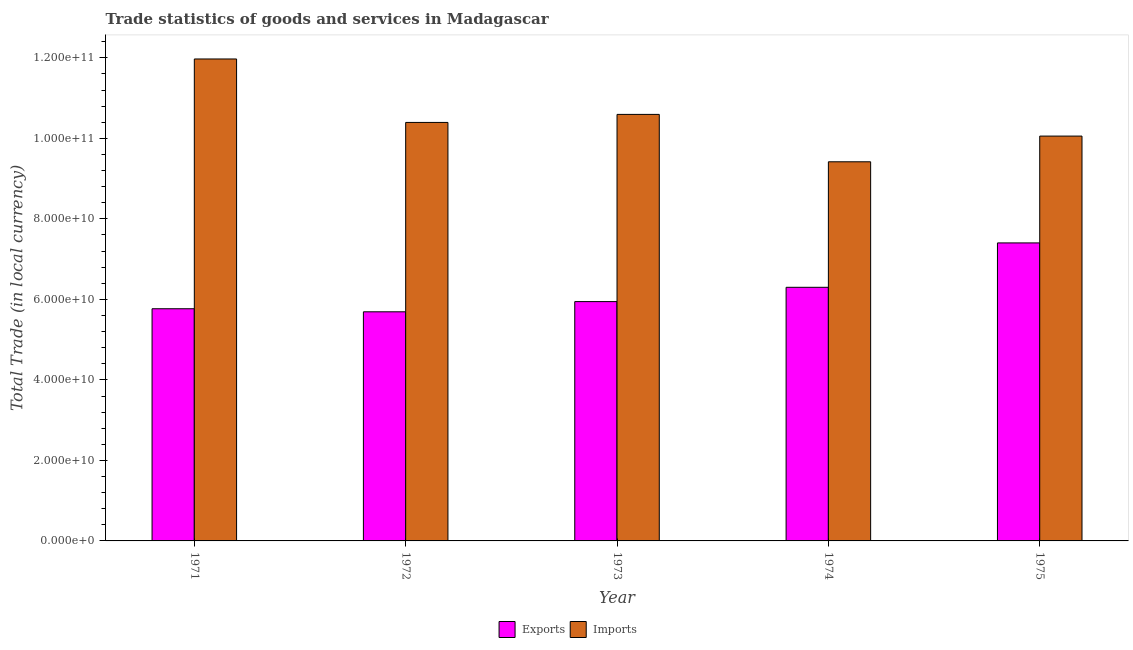How many different coloured bars are there?
Ensure brevity in your answer.  2. Are the number of bars per tick equal to the number of legend labels?
Make the answer very short. Yes. How many bars are there on the 4th tick from the right?
Offer a terse response. 2. What is the label of the 2nd group of bars from the left?
Your response must be concise. 1972. What is the imports of goods and services in 1972?
Your answer should be very brief. 1.04e+11. Across all years, what is the maximum export of goods and services?
Your response must be concise. 7.40e+1. Across all years, what is the minimum imports of goods and services?
Make the answer very short. 9.42e+1. In which year was the imports of goods and services maximum?
Make the answer very short. 1971. In which year was the export of goods and services minimum?
Your response must be concise. 1972. What is the total export of goods and services in the graph?
Ensure brevity in your answer.  3.11e+11. What is the difference between the export of goods and services in 1973 and that in 1974?
Offer a terse response. -3.55e+09. What is the difference between the imports of goods and services in 1973 and the export of goods and services in 1971?
Your answer should be compact. -1.38e+1. What is the average export of goods and services per year?
Give a very brief answer. 6.22e+1. What is the ratio of the imports of goods and services in 1972 to that in 1975?
Provide a succinct answer. 1.03. What is the difference between the highest and the second highest imports of goods and services?
Offer a terse response. 1.38e+1. What is the difference between the highest and the lowest export of goods and services?
Your answer should be compact. 1.71e+1. Is the sum of the imports of goods and services in 1971 and 1975 greater than the maximum export of goods and services across all years?
Provide a succinct answer. Yes. What does the 1st bar from the left in 1973 represents?
Provide a succinct answer. Exports. What does the 1st bar from the right in 1972 represents?
Provide a short and direct response. Imports. How many bars are there?
Your response must be concise. 10. What is the difference between two consecutive major ticks on the Y-axis?
Provide a short and direct response. 2.00e+1. Are the values on the major ticks of Y-axis written in scientific E-notation?
Ensure brevity in your answer.  Yes. Does the graph contain grids?
Give a very brief answer. No. How are the legend labels stacked?
Provide a succinct answer. Horizontal. What is the title of the graph?
Make the answer very short. Trade statistics of goods and services in Madagascar. What is the label or title of the X-axis?
Ensure brevity in your answer.  Year. What is the label or title of the Y-axis?
Keep it short and to the point. Total Trade (in local currency). What is the Total Trade (in local currency) in Exports in 1971?
Give a very brief answer. 5.77e+1. What is the Total Trade (in local currency) in Imports in 1971?
Make the answer very short. 1.20e+11. What is the Total Trade (in local currency) of Exports in 1972?
Provide a succinct answer. 5.69e+1. What is the Total Trade (in local currency) in Imports in 1972?
Provide a short and direct response. 1.04e+11. What is the Total Trade (in local currency) of Exports in 1973?
Your answer should be very brief. 5.95e+1. What is the Total Trade (in local currency) in Imports in 1973?
Your response must be concise. 1.06e+11. What is the Total Trade (in local currency) of Exports in 1974?
Give a very brief answer. 6.30e+1. What is the Total Trade (in local currency) in Imports in 1974?
Your answer should be compact. 9.42e+1. What is the Total Trade (in local currency) in Exports in 1975?
Give a very brief answer. 7.40e+1. What is the Total Trade (in local currency) in Imports in 1975?
Your response must be concise. 1.01e+11. Across all years, what is the maximum Total Trade (in local currency) of Exports?
Offer a terse response. 7.40e+1. Across all years, what is the maximum Total Trade (in local currency) of Imports?
Offer a very short reply. 1.20e+11. Across all years, what is the minimum Total Trade (in local currency) of Exports?
Ensure brevity in your answer.  5.69e+1. Across all years, what is the minimum Total Trade (in local currency) in Imports?
Ensure brevity in your answer.  9.42e+1. What is the total Total Trade (in local currency) in Exports in the graph?
Your answer should be very brief. 3.11e+11. What is the total Total Trade (in local currency) in Imports in the graph?
Offer a very short reply. 5.24e+11. What is the difference between the Total Trade (in local currency) of Exports in 1971 and that in 1972?
Provide a succinct answer. 7.61e+08. What is the difference between the Total Trade (in local currency) of Imports in 1971 and that in 1972?
Provide a succinct answer. 1.58e+1. What is the difference between the Total Trade (in local currency) in Exports in 1971 and that in 1973?
Offer a terse response. -1.77e+09. What is the difference between the Total Trade (in local currency) of Imports in 1971 and that in 1973?
Your answer should be compact. 1.38e+1. What is the difference between the Total Trade (in local currency) in Exports in 1971 and that in 1974?
Keep it short and to the point. -5.32e+09. What is the difference between the Total Trade (in local currency) of Imports in 1971 and that in 1974?
Ensure brevity in your answer.  2.55e+1. What is the difference between the Total Trade (in local currency) of Exports in 1971 and that in 1975?
Your response must be concise. -1.64e+1. What is the difference between the Total Trade (in local currency) of Imports in 1971 and that in 1975?
Provide a succinct answer. 1.92e+1. What is the difference between the Total Trade (in local currency) of Exports in 1972 and that in 1973?
Ensure brevity in your answer.  -2.54e+09. What is the difference between the Total Trade (in local currency) in Imports in 1972 and that in 1973?
Give a very brief answer. -2.00e+09. What is the difference between the Total Trade (in local currency) of Exports in 1972 and that in 1974?
Give a very brief answer. -6.08e+09. What is the difference between the Total Trade (in local currency) of Imports in 1972 and that in 1974?
Provide a succinct answer. 9.78e+09. What is the difference between the Total Trade (in local currency) of Exports in 1972 and that in 1975?
Give a very brief answer. -1.71e+1. What is the difference between the Total Trade (in local currency) of Imports in 1972 and that in 1975?
Ensure brevity in your answer.  3.39e+09. What is the difference between the Total Trade (in local currency) of Exports in 1973 and that in 1974?
Keep it short and to the point. -3.55e+09. What is the difference between the Total Trade (in local currency) of Imports in 1973 and that in 1974?
Keep it short and to the point. 1.18e+1. What is the difference between the Total Trade (in local currency) in Exports in 1973 and that in 1975?
Your answer should be very brief. -1.46e+1. What is the difference between the Total Trade (in local currency) in Imports in 1973 and that in 1975?
Offer a terse response. 5.39e+09. What is the difference between the Total Trade (in local currency) of Exports in 1974 and that in 1975?
Your answer should be very brief. -1.10e+1. What is the difference between the Total Trade (in local currency) in Imports in 1974 and that in 1975?
Offer a terse response. -6.39e+09. What is the difference between the Total Trade (in local currency) in Exports in 1971 and the Total Trade (in local currency) in Imports in 1972?
Ensure brevity in your answer.  -4.63e+1. What is the difference between the Total Trade (in local currency) in Exports in 1971 and the Total Trade (in local currency) in Imports in 1973?
Offer a terse response. -4.83e+1. What is the difference between the Total Trade (in local currency) in Exports in 1971 and the Total Trade (in local currency) in Imports in 1974?
Give a very brief answer. -3.65e+1. What is the difference between the Total Trade (in local currency) of Exports in 1971 and the Total Trade (in local currency) of Imports in 1975?
Your answer should be compact. -4.29e+1. What is the difference between the Total Trade (in local currency) of Exports in 1972 and the Total Trade (in local currency) of Imports in 1973?
Give a very brief answer. -4.90e+1. What is the difference between the Total Trade (in local currency) in Exports in 1972 and the Total Trade (in local currency) in Imports in 1974?
Ensure brevity in your answer.  -3.73e+1. What is the difference between the Total Trade (in local currency) in Exports in 1972 and the Total Trade (in local currency) in Imports in 1975?
Offer a very short reply. -4.37e+1. What is the difference between the Total Trade (in local currency) of Exports in 1973 and the Total Trade (in local currency) of Imports in 1974?
Keep it short and to the point. -3.47e+1. What is the difference between the Total Trade (in local currency) in Exports in 1973 and the Total Trade (in local currency) in Imports in 1975?
Keep it short and to the point. -4.11e+1. What is the difference between the Total Trade (in local currency) of Exports in 1974 and the Total Trade (in local currency) of Imports in 1975?
Give a very brief answer. -3.76e+1. What is the average Total Trade (in local currency) in Exports per year?
Your answer should be very brief. 6.22e+1. What is the average Total Trade (in local currency) of Imports per year?
Your response must be concise. 1.05e+11. In the year 1971, what is the difference between the Total Trade (in local currency) in Exports and Total Trade (in local currency) in Imports?
Make the answer very short. -6.20e+1. In the year 1972, what is the difference between the Total Trade (in local currency) of Exports and Total Trade (in local currency) of Imports?
Your answer should be very brief. -4.70e+1. In the year 1973, what is the difference between the Total Trade (in local currency) in Exports and Total Trade (in local currency) in Imports?
Give a very brief answer. -4.65e+1. In the year 1974, what is the difference between the Total Trade (in local currency) of Exports and Total Trade (in local currency) of Imports?
Give a very brief answer. -3.12e+1. In the year 1975, what is the difference between the Total Trade (in local currency) in Exports and Total Trade (in local currency) in Imports?
Your response must be concise. -2.65e+1. What is the ratio of the Total Trade (in local currency) in Exports in 1971 to that in 1972?
Your response must be concise. 1.01. What is the ratio of the Total Trade (in local currency) in Imports in 1971 to that in 1972?
Offer a very short reply. 1.15. What is the ratio of the Total Trade (in local currency) in Exports in 1971 to that in 1973?
Give a very brief answer. 0.97. What is the ratio of the Total Trade (in local currency) in Imports in 1971 to that in 1973?
Offer a terse response. 1.13. What is the ratio of the Total Trade (in local currency) of Exports in 1971 to that in 1974?
Provide a short and direct response. 0.92. What is the ratio of the Total Trade (in local currency) in Imports in 1971 to that in 1974?
Offer a terse response. 1.27. What is the ratio of the Total Trade (in local currency) of Exports in 1971 to that in 1975?
Make the answer very short. 0.78. What is the ratio of the Total Trade (in local currency) of Imports in 1971 to that in 1975?
Give a very brief answer. 1.19. What is the ratio of the Total Trade (in local currency) in Exports in 1972 to that in 1973?
Provide a short and direct response. 0.96. What is the ratio of the Total Trade (in local currency) of Imports in 1972 to that in 1973?
Make the answer very short. 0.98. What is the ratio of the Total Trade (in local currency) of Exports in 1972 to that in 1974?
Your answer should be compact. 0.9. What is the ratio of the Total Trade (in local currency) in Imports in 1972 to that in 1974?
Provide a short and direct response. 1.1. What is the ratio of the Total Trade (in local currency) of Exports in 1972 to that in 1975?
Ensure brevity in your answer.  0.77. What is the ratio of the Total Trade (in local currency) in Imports in 1972 to that in 1975?
Ensure brevity in your answer.  1.03. What is the ratio of the Total Trade (in local currency) in Exports in 1973 to that in 1974?
Keep it short and to the point. 0.94. What is the ratio of the Total Trade (in local currency) of Exports in 1973 to that in 1975?
Keep it short and to the point. 0.8. What is the ratio of the Total Trade (in local currency) in Imports in 1973 to that in 1975?
Give a very brief answer. 1.05. What is the ratio of the Total Trade (in local currency) of Exports in 1974 to that in 1975?
Keep it short and to the point. 0.85. What is the ratio of the Total Trade (in local currency) in Imports in 1974 to that in 1975?
Ensure brevity in your answer.  0.94. What is the difference between the highest and the second highest Total Trade (in local currency) in Exports?
Make the answer very short. 1.10e+1. What is the difference between the highest and the second highest Total Trade (in local currency) of Imports?
Keep it short and to the point. 1.38e+1. What is the difference between the highest and the lowest Total Trade (in local currency) in Exports?
Ensure brevity in your answer.  1.71e+1. What is the difference between the highest and the lowest Total Trade (in local currency) of Imports?
Give a very brief answer. 2.55e+1. 